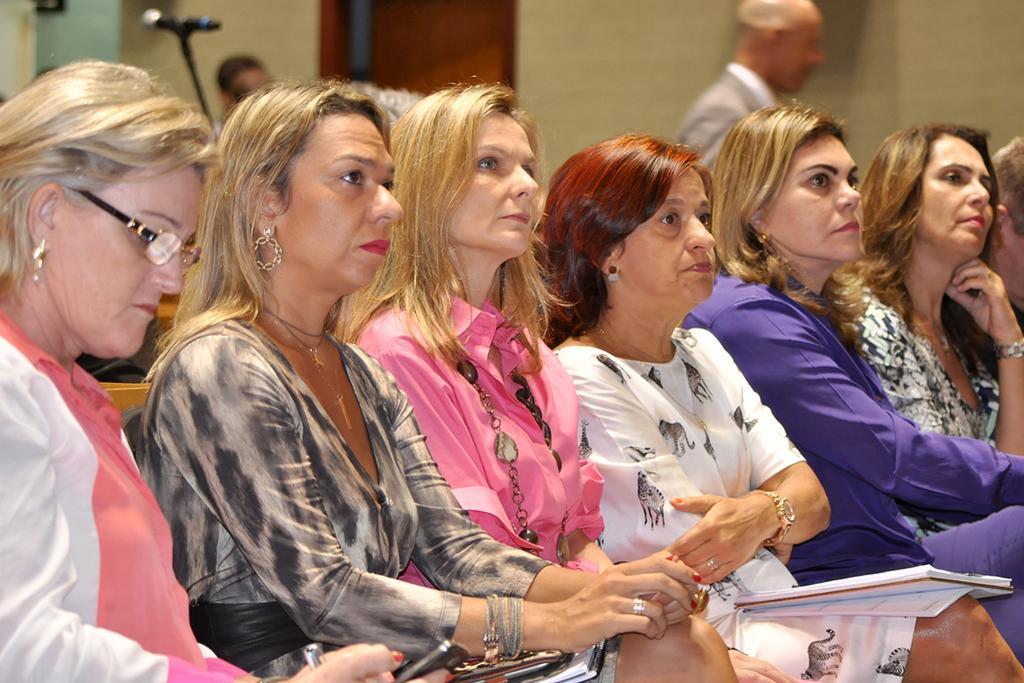In one or two sentences, can you explain what this image depicts? In the foreground of this picture, there are women sitting. In the background, there is a man, mic, two heads of the person, door and the wall. 